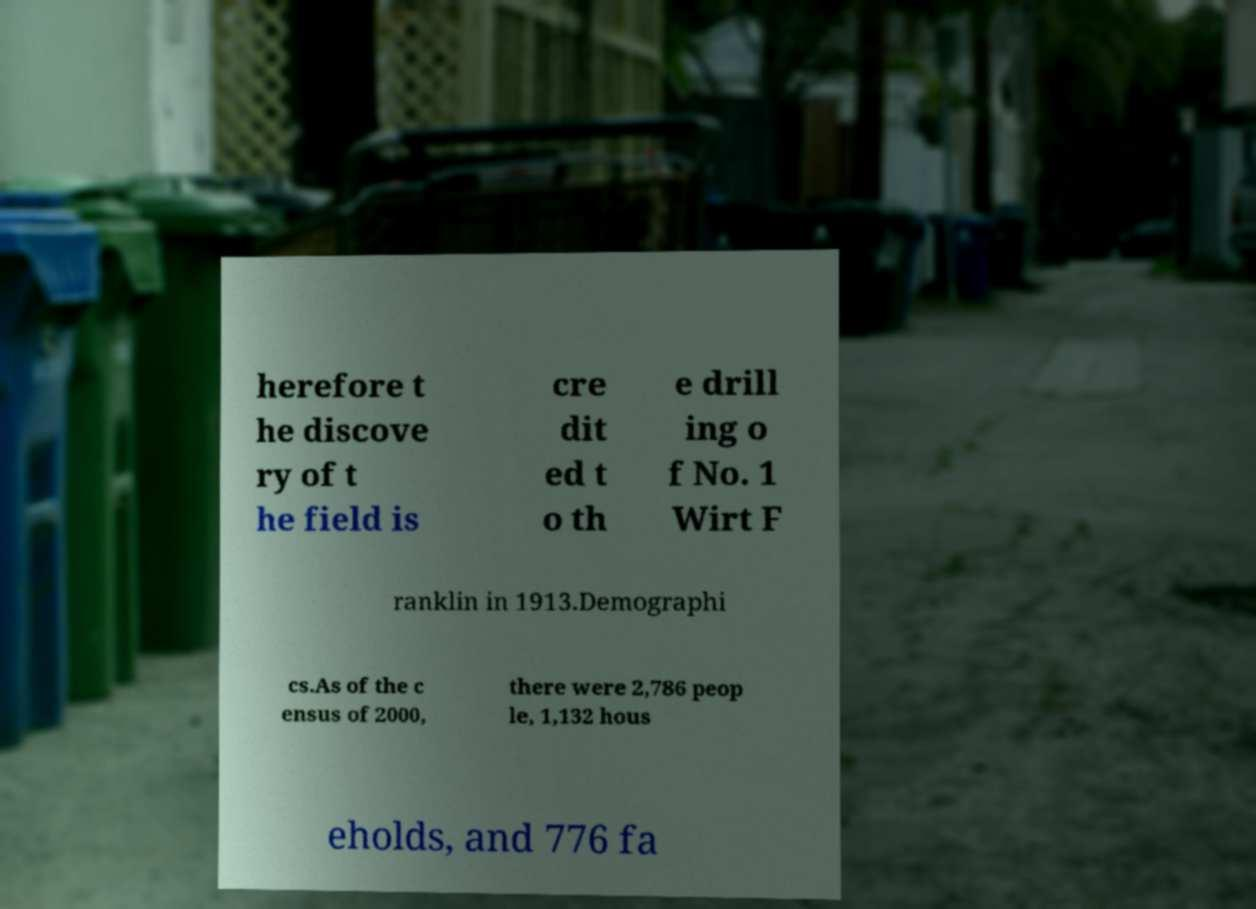Please read and relay the text visible in this image. What does it say? herefore t he discove ry of t he field is cre dit ed t o th e drill ing o f No. 1 Wirt F ranklin in 1913.Demographi cs.As of the c ensus of 2000, there were 2,786 peop le, 1,132 hous eholds, and 776 fa 